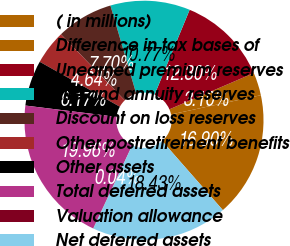<chart> <loc_0><loc_0><loc_500><loc_500><pie_chart><fcel>( in millions)<fcel>Difference in tax bases of<fcel>Unearned premium reserves<fcel>Life and annuity reserves<fcel>Discount on loss reserves<fcel>Other postretirement benefits<fcel>Other assets<fcel>Total deferred assets<fcel>Valuation allowance<fcel>Net deferred assets<nl><fcel>16.9%<fcel>3.1%<fcel>12.3%<fcel>10.77%<fcel>7.7%<fcel>4.64%<fcel>6.17%<fcel>19.96%<fcel>0.04%<fcel>18.43%<nl></chart> 